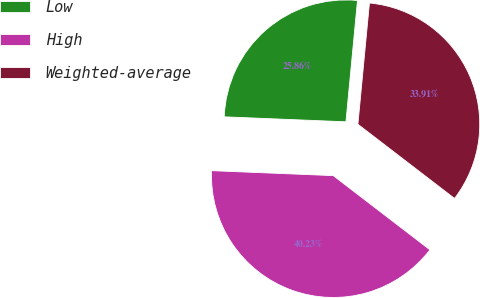Convert chart to OTSL. <chart><loc_0><loc_0><loc_500><loc_500><pie_chart><fcel>Low<fcel>High<fcel>Weighted-average<nl><fcel>25.86%<fcel>40.23%<fcel>33.91%<nl></chart> 